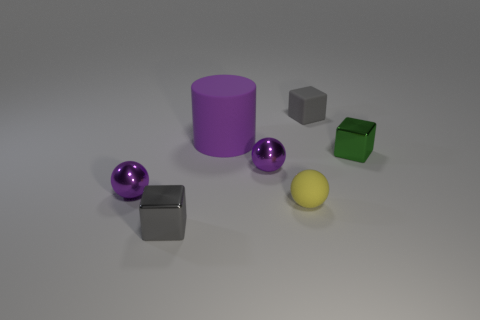Subtract all purple spheres. How many were subtracted if there are1purple spheres left? 1 Add 3 small matte spheres. How many objects exist? 10 Subtract all cubes. How many objects are left? 4 Subtract 0 red cubes. How many objects are left? 7 Subtract all gray rubber blocks. Subtract all tiny rubber spheres. How many objects are left? 5 Add 3 rubber cylinders. How many rubber cylinders are left? 4 Add 6 tiny green metal objects. How many tiny green metal objects exist? 7 